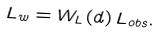<formula> <loc_0><loc_0><loc_500><loc_500>L _ { w } = W _ { L } ( d ) \, L _ { o b s } .</formula> 